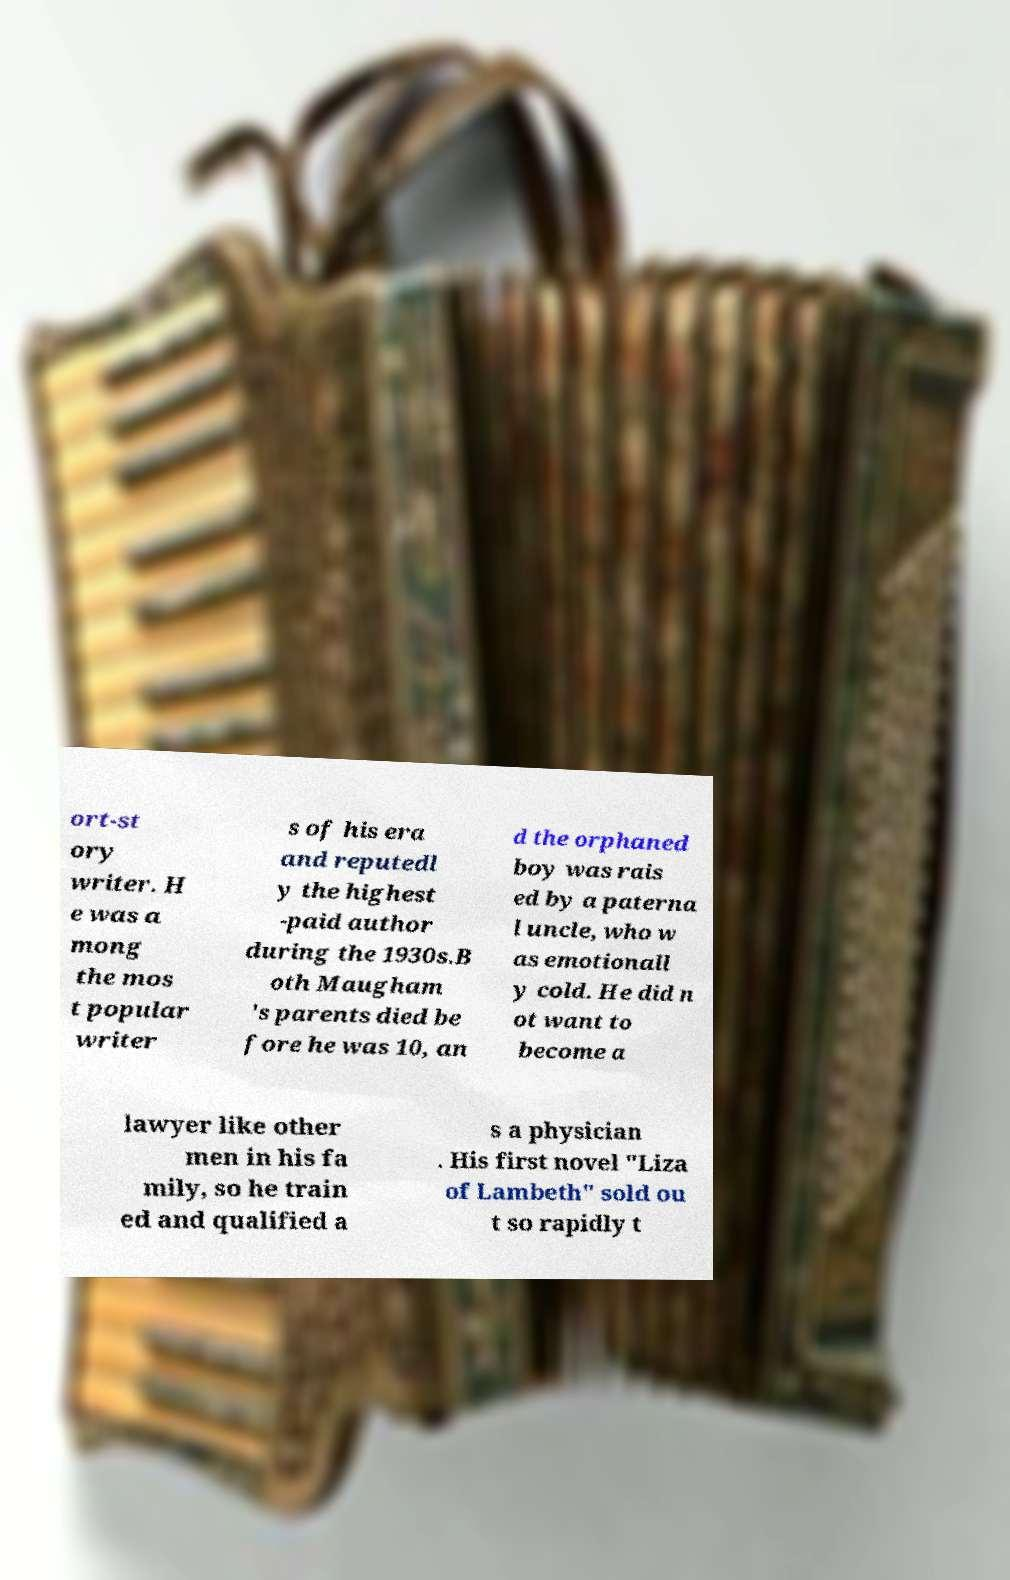I need the written content from this picture converted into text. Can you do that? ort-st ory writer. H e was a mong the mos t popular writer s of his era and reputedl y the highest -paid author during the 1930s.B oth Maugham 's parents died be fore he was 10, an d the orphaned boy was rais ed by a paterna l uncle, who w as emotionall y cold. He did n ot want to become a lawyer like other men in his fa mily, so he train ed and qualified a s a physician . His first novel "Liza of Lambeth" sold ou t so rapidly t 